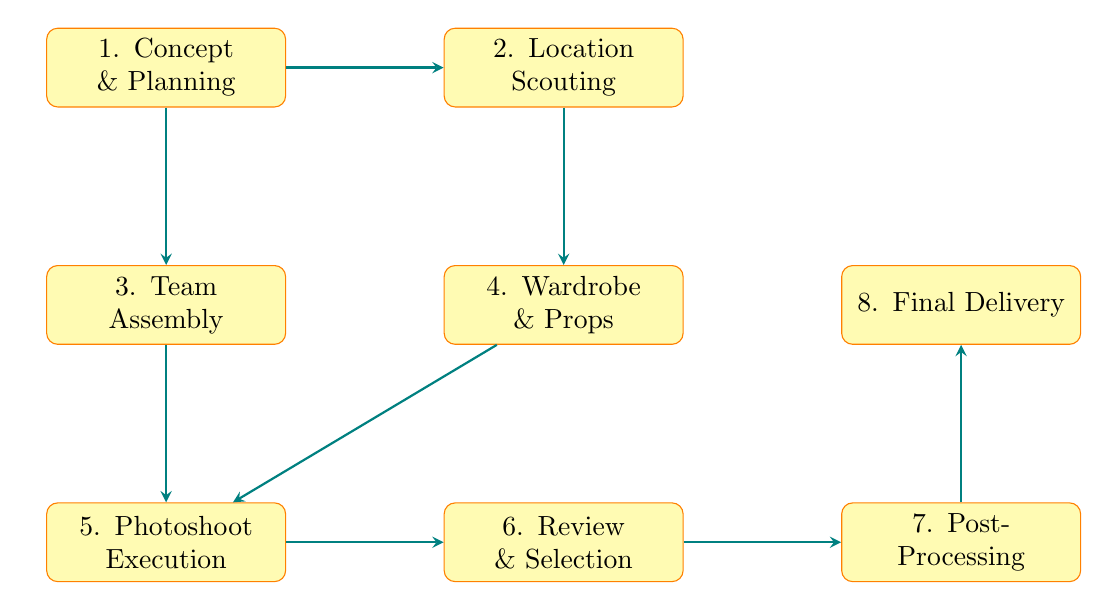What is the first step in the workflow? The first step is represented by the node labeled "1. Concept & Planning." This node indicates the starting point of the workflow, where the vision, theme, and mood for the photoshoot are defined.
Answer: Concept & Planning How many total steps are there in the diagram? To find the total steps, we can count each unique node in the diagram. There are eight nodes identified in the workflow, which represent the distinct steps in the fashion photoshoot process.
Answer: 8 What is the node directly below "2. Location Scouting"? The node directly below "2. Location Scouting" is "4. Wardrobe & Props." This indicates that after scouting for locations, the next step involves gathering clothing and props necessary for the shoot.
Answer: 4. Wardrobe & Props What is the last step in the fashion photoshoot workflow? The last step is denoted by the node "8. Final Delivery." This step involves delivering the finished photos to the client or publication, making it the final stage in the process.
Answer: Final Delivery What is the relationship between "5. Photoshoot Execution" and "6. Review & Selection"? The relationship between these two nodes shows a direct flow from "5. Photoshoot Execution" to "6. Review & Selection." This indicates that after executing the photoshoot, the next logical step is to review the captured photos and select the best shots.
Answer: Direct flow 